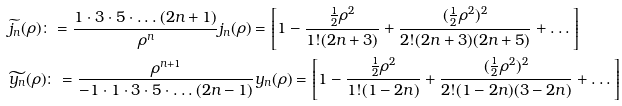<formula> <loc_0><loc_0><loc_500><loc_500>& \widetilde { j _ { n } } ( \rho ) \colon = \frac { 1 \cdot 3 \cdot 5 \cdot \dots ( 2 n + 1 ) } { \rho ^ { n } } j _ { n } ( \rho ) = \left [ 1 - \frac { \frac { 1 } { 2 } \rho ^ { 2 } } { 1 ! ( 2 n + 3 ) } + \frac { ( { \frac { 1 } { 2 } \rho ^ { 2 } } ) ^ { 2 } } { 2 ! ( 2 n + 3 ) ( 2 n + 5 ) } + \dots \right ] \\ & \widetilde { y _ { n } } ( \rho ) \colon = \frac { \rho ^ { n + 1 } } { - 1 \cdot 1 \cdot 3 \cdot 5 \cdot \dots ( 2 n - 1 ) } y _ { n } ( \rho ) = \left [ 1 - \frac { \frac { 1 } { 2 } \rho ^ { 2 } } { 1 ! ( 1 - 2 n ) } + \frac { ( { \frac { 1 } { 2 } \rho ^ { 2 } } ) ^ { 2 } } { 2 ! ( 1 - 2 n ) ( 3 - 2 n ) } + \dots \right ] \\</formula> 